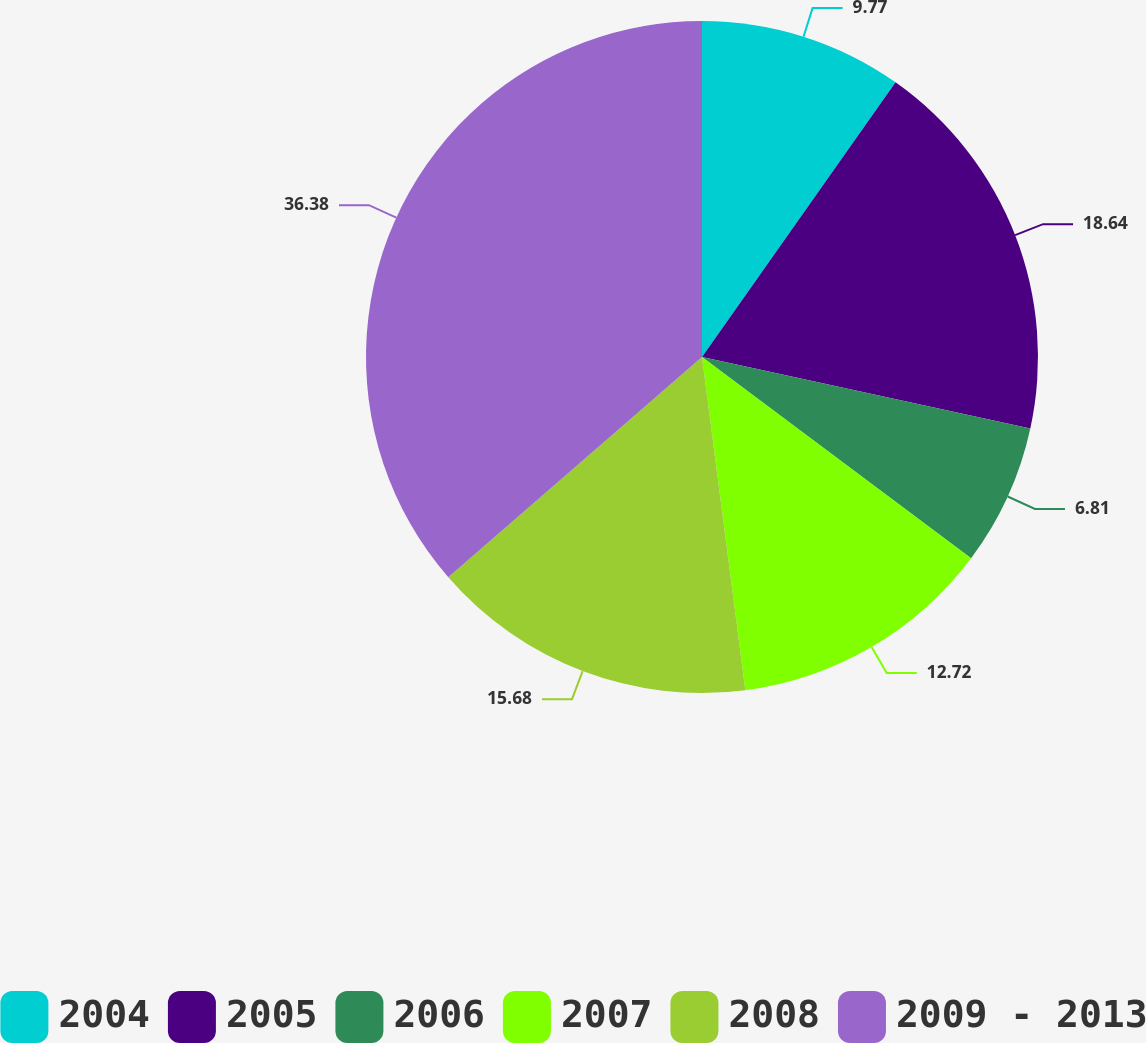<chart> <loc_0><loc_0><loc_500><loc_500><pie_chart><fcel>2004<fcel>2005<fcel>2006<fcel>2007<fcel>2008<fcel>2009 - 2013<nl><fcel>9.77%<fcel>18.64%<fcel>6.81%<fcel>12.72%<fcel>15.68%<fcel>36.38%<nl></chart> 